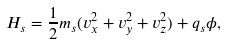<formula> <loc_0><loc_0><loc_500><loc_500>H _ { s } = \frac { 1 } { 2 } m _ { s } ( v _ { x } ^ { 2 } + v _ { y } ^ { 2 } + v _ { z } ^ { 2 } ) + q _ { s } \phi ,</formula> 